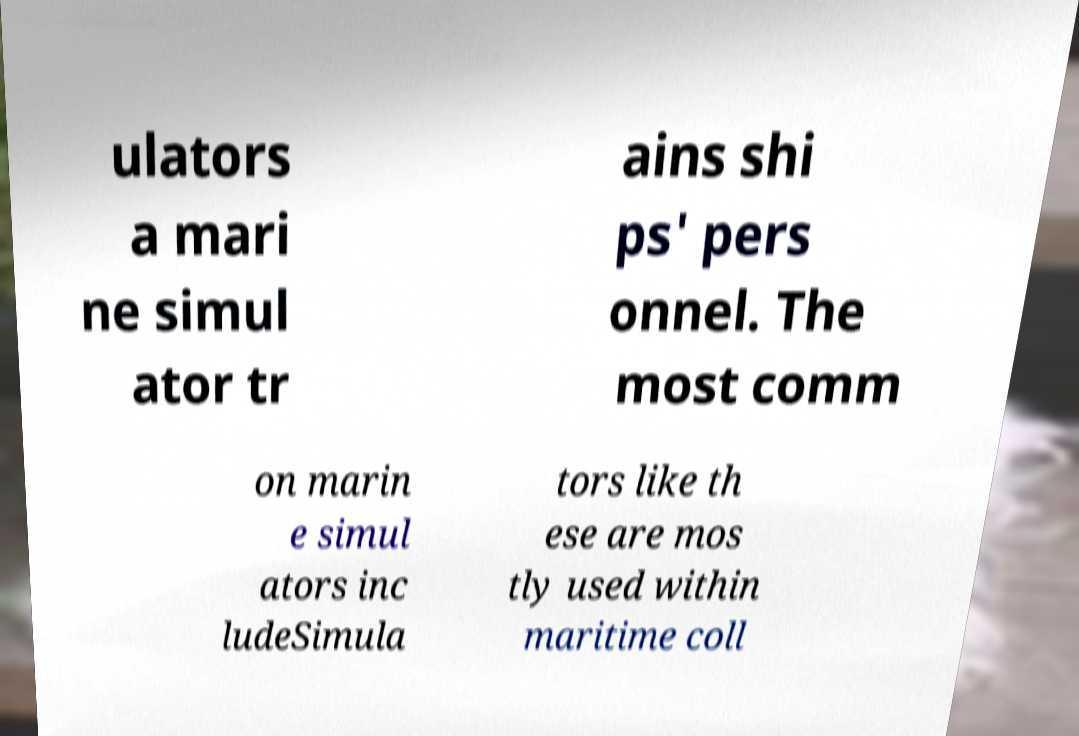Please identify and transcribe the text found in this image. ulators a mari ne simul ator tr ains shi ps' pers onnel. The most comm on marin e simul ators inc ludeSimula tors like th ese are mos tly used within maritime coll 